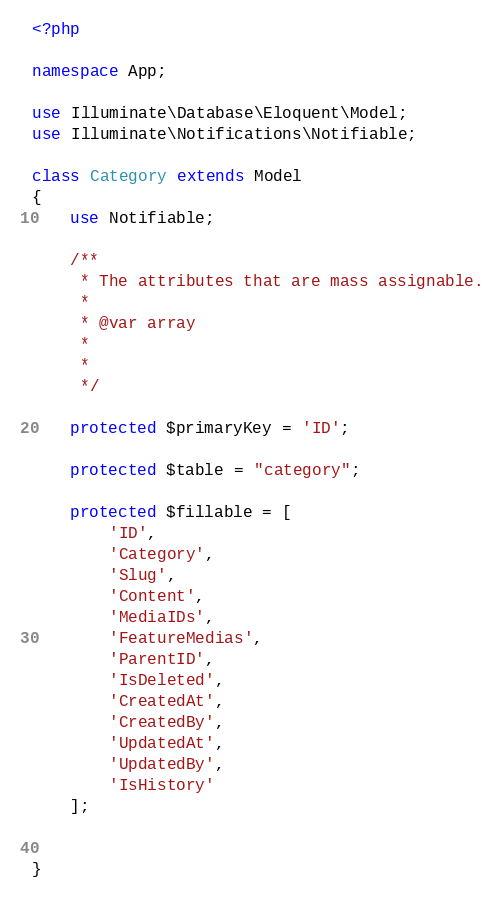<code> <loc_0><loc_0><loc_500><loc_500><_PHP_><?php

namespace App;

use Illuminate\Database\Eloquent\Model;
use Illuminate\Notifications\Notifiable;

class Category extends Model
{
    use Notifiable;

    /**
     * The attributes that are mass assignable.
     *
     * @var array
     *
     *
     */

    protected $primaryKey = 'ID';

    protected $table = "category";

    protected $fillable = [
        'ID',
        'Category',
        'Slug',
        'Content',
        'MediaIDs',
        'FeatureMedias',
        'ParentID',
        'IsDeleted',
        'CreatedAt',
        'CreatedBy',
        'UpdatedAt',
        'UpdatedBy',
        'IsHistory'
    ];


}
</code> 